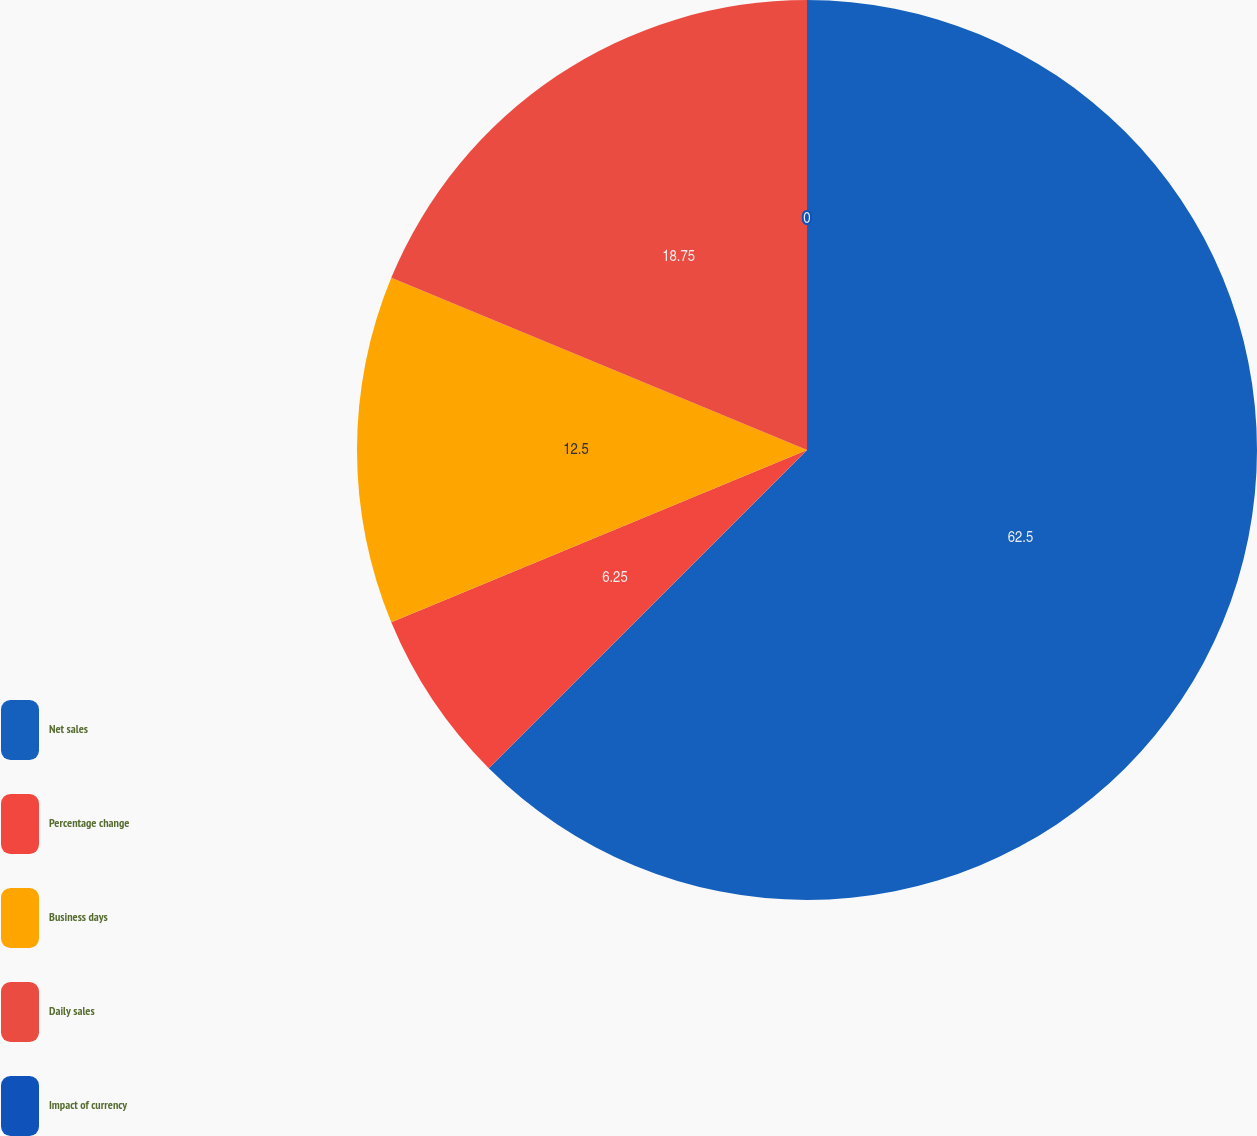Convert chart. <chart><loc_0><loc_0><loc_500><loc_500><pie_chart><fcel>Net sales<fcel>Percentage change<fcel>Business days<fcel>Daily sales<fcel>Impact of currency<nl><fcel>62.5%<fcel>6.25%<fcel>12.5%<fcel>18.75%<fcel>0.0%<nl></chart> 